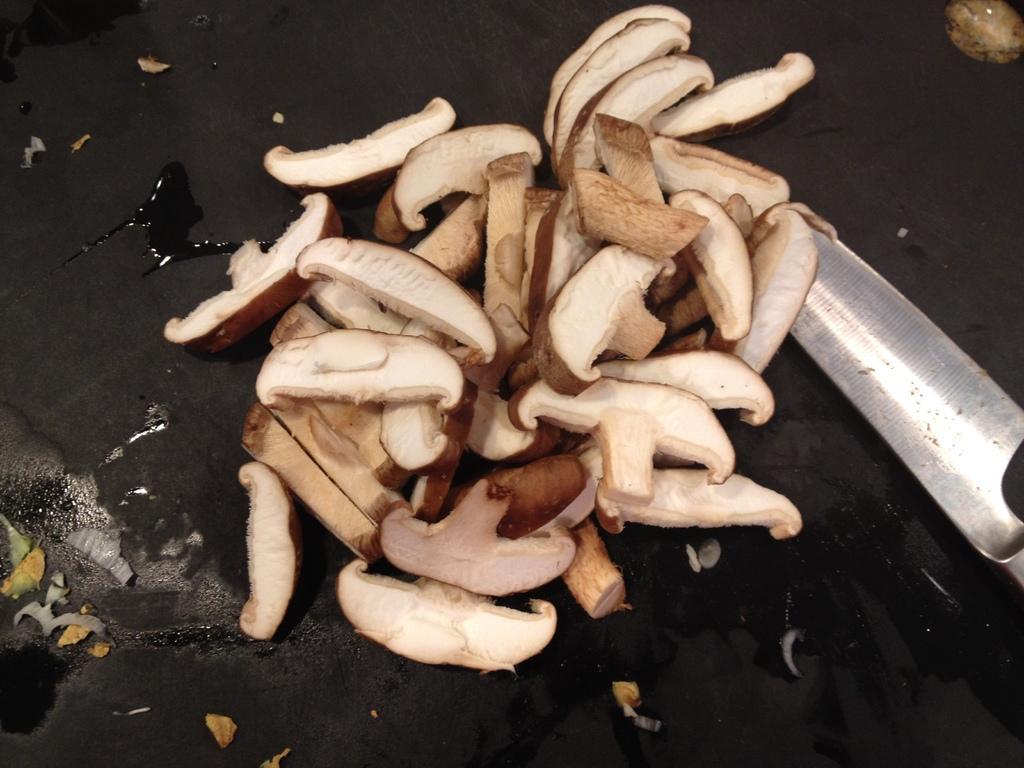How would you summarize this image in a sentence or two? In this image there are mushrooms and there is a knife and there is a black background, it might be a pan. 